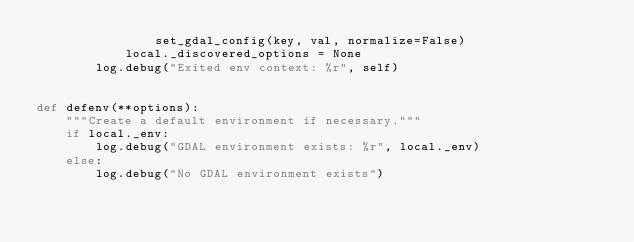Convert code to text. <code><loc_0><loc_0><loc_500><loc_500><_Python_>                set_gdal_config(key, val, normalize=False)
            local._discovered_options = None
        log.debug("Exited env context: %r", self)


def defenv(**options):
    """Create a default environment if necessary."""
    if local._env:
        log.debug("GDAL environment exists: %r", local._env)
    else:
        log.debug("No GDAL environment exists")</code> 